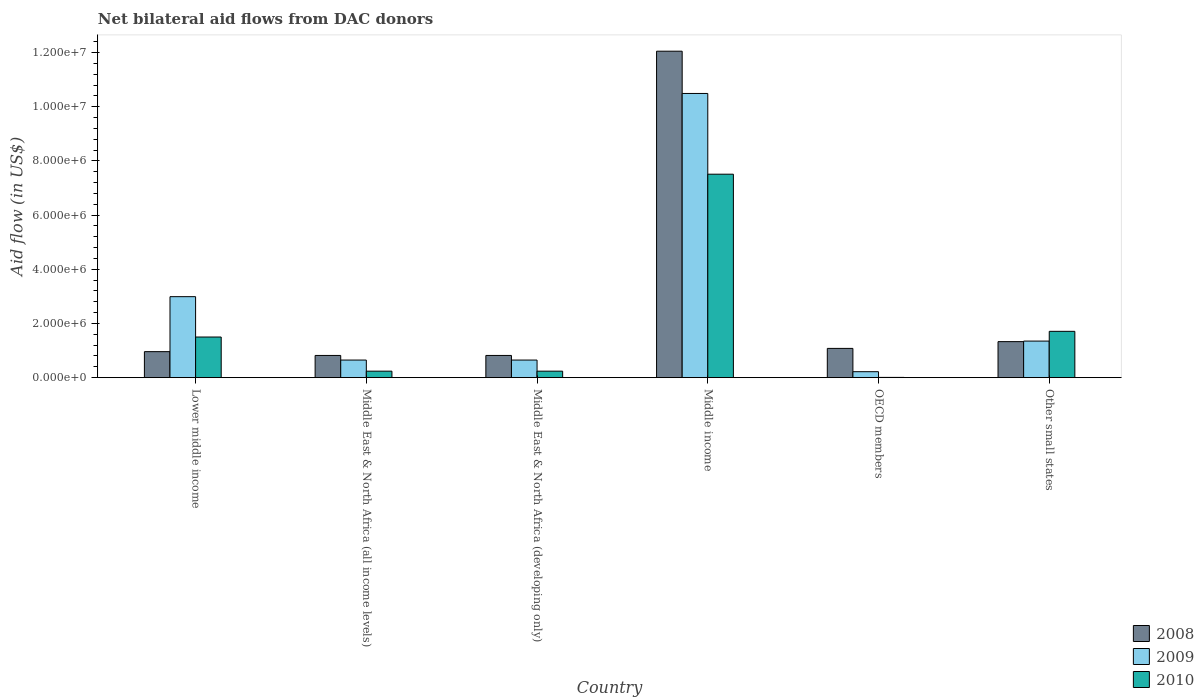How many different coloured bars are there?
Your answer should be very brief. 3. Are the number of bars on each tick of the X-axis equal?
Keep it short and to the point. Yes. How many bars are there on the 1st tick from the left?
Offer a very short reply. 3. How many bars are there on the 4th tick from the right?
Your answer should be very brief. 3. What is the label of the 5th group of bars from the left?
Keep it short and to the point. OECD members. What is the net bilateral aid flow in 2009 in Middle income?
Provide a short and direct response. 1.05e+07. Across all countries, what is the maximum net bilateral aid flow in 2009?
Keep it short and to the point. 1.05e+07. Across all countries, what is the minimum net bilateral aid flow in 2009?
Your response must be concise. 2.20e+05. In which country was the net bilateral aid flow in 2009 minimum?
Offer a terse response. OECD members. What is the total net bilateral aid flow in 2009 in the graph?
Offer a terse response. 1.64e+07. What is the difference between the net bilateral aid flow in 2008 in Middle East & North Africa (developing only) and that in OECD members?
Offer a very short reply. -2.60e+05. What is the difference between the net bilateral aid flow in 2008 in Middle East & North Africa (all income levels) and the net bilateral aid flow in 2010 in Other small states?
Keep it short and to the point. -8.90e+05. What is the average net bilateral aid flow in 2010 per country?
Provide a succinct answer. 1.87e+06. What is the difference between the net bilateral aid flow of/in 2009 and net bilateral aid flow of/in 2010 in Lower middle income?
Your response must be concise. 1.49e+06. In how many countries, is the net bilateral aid flow in 2010 greater than 6800000 US$?
Offer a very short reply. 1. What is the ratio of the net bilateral aid flow in 2008 in Middle East & North Africa (developing only) to that in Other small states?
Offer a very short reply. 0.62. Is the net bilateral aid flow in 2010 in Middle income less than that in OECD members?
Provide a short and direct response. No. Is the difference between the net bilateral aid flow in 2009 in OECD members and Other small states greater than the difference between the net bilateral aid flow in 2010 in OECD members and Other small states?
Provide a succinct answer. Yes. What is the difference between the highest and the second highest net bilateral aid flow in 2008?
Ensure brevity in your answer.  1.07e+07. What is the difference between the highest and the lowest net bilateral aid flow in 2009?
Your answer should be very brief. 1.03e+07. In how many countries, is the net bilateral aid flow in 2009 greater than the average net bilateral aid flow in 2009 taken over all countries?
Offer a very short reply. 2. What does the 1st bar from the left in Other small states represents?
Your response must be concise. 2008. What does the 3rd bar from the right in Middle income represents?
Provide a short and direct response. 2008. How many bars are there?
Offer a very short reply. 18. How many countries are there in the graph?
Offer a terse response. 6. Where does the legend appear in the graph?
Keep it short and to the point. Bottom right. How are the legend labels stacked?
Give a very brief answer. Vertical. What is the title of the graph?
Offer a very short reply. Net bilateral aid flows from DAC donors. Does "1963" appear as one of the legend labels in the graph?
Ensure brevity in your answer.  No. What is the label or title of the X-axis?
Your answer should be very brief. Country. What is the label or title of the Y-axis?
Ensure brevity in your answer.  Aid flow (in US$). What is the Aid flow (in US$) in 2008 in Lower middle income?
Your answer should be very brief. 9.60e+05. What is the Aid flow (in US$) of 2009 in Lower middle income?
Make the answer very short. 2.99e+06. What is the Aid flow (in US$) in 2010 in Lower middle income?
Provide a short and direct response. 1.50e+06. What is the Aid flow (in US$) of 2008 in Middle East & North Africa (all income levels)?
Your response must be concise. 8.20e+05. What is the Aid flow (in US$) of 2009 in Middle East & North Africa (all income levels)?
Your answer should be compact. 6.50e+05. What is the Aid flow (in US$) of 2010 in Middle East & North Africa (all income levels)?
Your answer should be compact. 2.40e+05. What is the Aid flow (in US$) in 2008 in Middle East & North Africa (developing only)?
Your response must be concise. 8.20e+05. What is the Aid flow (in US$) of 2009 in Middle East & North Africa (developing only)?
Give a very brief answer. 6.50e+05. What is the Aid flow (in US$) of 2008 in Middle income?
Keep it short and to the point. 1.20e+07. What is the Aid flow (in US$) in 2009 in Middle income?
Keep it short and to the point. 1.05e+07. What is the Aid flow (in US$) in 2010 in Middle income?
Your answer should be compact. 7.51e+06. What is the Aid flow (in US$) of 2008 in OECD members?
Give a very brief answer. 1.08e+06. What is the Aid flow (in US$) of 2009 in OECD members?
Make the answer very short. 2.20e+05. What is the Aid flow (in US$) of 2010 in OECD members?
Give a very brief answer. 10000. What is the Aid flow (in US$) in 2008 in Other small states?
Keep it short and to the point. 1.33e+06. What is the Aid flow (in US$) of 2009 in Other small states?
Provide a short and direct response. 1.35e+06. What is the Aid flow (in US$) in 2010 in Other small states?
Your response must be concise. 1.71e+06. Across all countries, what is the maximum Aid flow (in US$) of 2008?
Offer a terse response. 1.20e+07. Across all countries, what is the maximum Aid flow (in US$) of 2009?
Your response must be concise. 1.05e+07. Across all countries, what is the maximum Aid flow (in US$) in 2010?
Keep it short and to the point. 7.51e+06. Across all countries, what is the minimum Aid flow (in US$) of 2008?
Give a very brief answer. 8.20e+05. Across all countries, what is the minimum Aid flow (in US$) in 2009?
Provide a succinct answer. 2.20e+05. Across all countries, what is the minimum Aid flow (in US$) in 2010?
Keep it short and to the point. 10000. What is the total Aid flow (in US$) in 2008 in the graph?
Give a very brief answer. 1.71e+07. What is the total Aid flow (in US$) of 2009 in the graph?
Your response must be concise. 1.64e+07. What is the total Aid flow (in US$) of 2010 in the graph?
Offer a very short reply. 1.12e+07. What is the difference between the Aid flow (in US$) in 2009 in Lower middle income and that in Middle East & North Africa (all income levels)?
Make the answer very short. 2.34e+06. What is the difference between the Aid flow (in US$) in 2010 in Lower middle income and that in Middle East & North Africa (all income levels)?
Offer a terse response. 1.26e+06. What is the difference between the Aid flow (in US$) in 2008 in Lower middle income and that in Middle East & North Africa (developing only)?
Offer a very short reply. 1.40e+05. What is the difference between the Aid flow (in US$) of 2009 in Lower middle income and that in Middle East & North Africa (developing only)?
Offer a terse response. 2.34e+06. What is the difference between the Aid flow (in US$) of 2010 in Lower middle income and that in Middle East & North Africa (developing only)?
Keep it short and to the point. 1.26e+06. What is the difference between the Aid flow (in US$) in 2008 in Lower middle income and that in Middle income?
Ensure brevity in your answer.  -1.11e+07. What is the difference between the Aid flow (in US$) of 2009 in Lower middle income and that in Middle income?
Give a very brief answer. -7.50e+06. What is the difference between the Aid flow (in US$) in 2010 in Lower middle income and that in Middle income?
Offer a very short reply. -6.01e+06. What is the difference between the Aid flow (in US$) in 2008 in Lower middle income and that in OECD members?
Give a very brief answer. -1.20e+05. What is the difference between the Aid flow (in US$) of 2009 in Lower middle income and that in OECD members?
Offer a terse response. 2.77e+06. What is the difference between the Aid flow (in US$) of 2010 in Lower middle income and that in OECD members?
Provide a succinct answer. 1.49e+06. What is the difference between the Aid flow (in US$) in 2008 in Lower middle income and that in Other small states?
Provide a short and direct response. -3.70e+05. What is the difference between the Aid flow (in US$) of 2009 in Lower middle income and that in Other small states?
Keep it short and to the point. 1.64e+06. What is the difference between the Aid flow (in US$) of 2009 in Middle East & North Africa (all income levels) and that in Middle East & North Africa (developing only)?
Provide a succinct answer. 0. What is the difference between the Aid flow (in US$) of 2008 in Middle East & North Africa (all income levels) and that in Middle income?
Make the answer very short. -1.12e+07. What is the difference between the Aid flow (in US$) in 2009 in Middle East & North Africa (all income levels) and that in Middle income?
Offer a very short reply. -9.84e+06. What is the difference between the Aid flow (in US$) of 2010 in Middle East & North Africa (all income levels) and that in Middle income?
Keep it short and to the point. -7.27e+06. What is the difference between the Aid flow (in US$) of 2009 in Middle East & North Africa (all income levels) and that in OECD members?
Your response must be concise. 4.30e+05. What is the difference between the Aid flow (in US$) of 2010 in Middle East & North Africa (all income levels) and that in OECD members?
Offer a terse response. 2.30e+05. What is the difference between the Aid flow (in US$) in 2008 in Middle East & North Africa (all income levels) and that in Other small states?
Provide a short and direct response. -5.10e+05. What is the difference between the Aid flow (in US$) in 2009 in Middle East & North Africa (all income levels) and that in Other small states?
Keep it short and to the point. -7.00e+05. What is the difference between the Aid flow (in US$) of 2010 in Middle East & North Africa (all income levels) and that in Other small states?
Give a very brief answer. -1.47e+06. What is the difference between the Aid flow (in US$) in 2008 in Middle East & North Africa (developing only) and that in Middle income?
Give a very brief answer. -1.12e+07. What is the difference between the Aid flow (in US$) of 2009 in Middle East & North Africa (developing only) and that in Middle income?
Give a very brief answer. -9.84e+06. What is the difference between the Aid flow (in US$) of 2010 in Middle East & North Africa (developing only) and that in Middle income?
Ensure brevity in your answer.  -7.27e+06. What is the difference between the Aid flow (in US$) in 2008 in Middle East & North Africa (developing only) and that in OECD members?
Make the answer very short. -2.60e+05. What is the difference between the Aid flow (in US$) of 2009 in Middle East & North Africa (developing only) and that in OECD members?
Provide a short and direct response. 4.30e+05. What is the difference between the Aid flow (in US$) of 2008 in Middle East & North Africa (developing only) and that in Other small states?
Ensure brevity in your answer.  -5.10e+05. What is the difference between the Aid flow (in US$) in 2009 in Middle East & North Africa (developing only) and that in Other small states?
Your answer should be very brief. -7.00e+05. What is the difference between the Aid flow (in US$) of 2010 in Middle East & North Africa (developing only) and that in Other small states?
Make the answer very short. -1.47e+06. What is the difference between the Aid flow (in US$) of 2008 in Middle income and that in OECD members?
Your answer should be very brief. 1.10e+07. What is the difference between the Aid flow (in US$) in 2009 in Middle income and that in OECD members?
Your answer should be compact. 1.03e+07. What is the difference between the Aid flow (in US$) of 2010 in Middle income and that in OECD members?
Offer a very short reply. 7.50e+06. What is the difference between the Aid flow (in US$) in 2008 in Middle income and that in Other small states?
Your response must be concise. 1.07e+07. What is the difference between the Aid flow (in US$) in 2009 in Middle income and that in Other small states?
Give a very brief answer. 9.14e+06. What is the difference between the Aid flow (in US$) in 2010 in Middle income and that in Other small states?
Keep it short and to the point. 5.80e+06. What is the difference between the Aid flow (in US$) in 2009 in OECD members and that in Other small states?
Offer a terse response. -1.13e+06. What is the difference between the Aid flow (in US$) in 2010 in OECD members and that in Other small states?
Ensure brevity in your answer.  -1.70e+06. What is the difference between the Aid flow (in US$) in 2008 in Lower middle income and the Aid flow (in US$) in 2009 in Middle East & North Africa (all income levels)?
Make the answer very short. 3.10e+05. What is the difference between the Aid flow (in US$) in 2008 in Lower middle income and the Aid flow (in US$) in 2010 in Middle East & North Africa (all income levels)?
Offer a very short reply. 7.20e+05. What is the difference between the Aid flow (in US$) of 2009 in Lower middle income and the Aid flow (in US$) of 2010 in Middle East & North Africa (all income levels)?
Your answer should be compact. 2.75e+06. What is the difference between the Aid flow (in US$) of 2008 in Lower middle income and the Aid flow (in US$) of 2010 in Middle East & North Africa (developing only)?
Ensure brevity in your answer.  7.20e+05. What is the difference between the Aid flow (in US$) in 2009 in Lower middle income and the Aid flow (in US$) in 2010 in Middle East & North Africa (developing only)?
Your response must be concise. 2.75e+06. What is the difference between the Aid flow (in US$) of 2008 in Lower middle income and the Aid flow (in US$) of 2009 in Middle income?
Your answer should be very brief. -9.53e+06. What is the difference between the Aid flow (in US$) in 2008 in Lower middle income and the Aid flow (in US$) in 2010 in Middle income?
Offer a very short reply. -6.55e+06. What is the difference between the Aid flow (in US$) of 2009 in Lower middle income and the Aid flow (in US$) of 2010 in Middle income?
Provide a short and direct response. -4.52e+06. What is the difference between the Aid flow (in US$) of 2008 in Lower middle income and the Aid flow (in US$) of 2009 in OECD members?
Offer a terse response. 7.40e+05. What is the difference between the Aid flow (in US$) of 2008 in Lower middle income and the Aid flow (in US$) of 2010 in OECD members?
Ensure brevity in your answer.  9.50e+05. What is the difference between the Aid flow (in US$) of 2009 in Lower middle income and the Aid flow (in US$) of 2010 in OECD members?
Keep it short and to the point. 2.98e+06. What is the difference between the Aid flow (in US$) of 2008 in Lower middle income and the Aid flow (in US$) of 2009 in Other small states?
Provide a short and direct response. -3.90e+05. What is the difference between the Aid flow (in US$) in 2008 in Lower middle income and the Aid flow (in US$) in 2010 in Other small states?
Offer a terse response. -7.50e+05. What is the difference between the Aid flow (in US$) of 2009 in Lower middle income and the Aid flow (in US$) of 2010 in Other small states?
Offer a terse response. 1.28e+06. What is the difference between the Aid flow (in US$) in 2008 in Middle East & North Africa (all income levels) and the Aid flow (in US$) in 2009 in Middle East & North Africa (developing only)?
Give a very brief answer. 1.70e+05. What is the difference between the Aid flow (in US$) in 2008 in Middle East & North Africa (all income levels) and the Aid flow (in US$) in 2010 in Middle East & North Africa (developing only)?
Offer a very short reply. 5.80e+05. What is the difference between the Aid flow (in US$) of 2009 in Middle East & North Africa (all income levels) and the Aid flow (in US$) of 2010 in Middle East & North Africa (developing only)?
Offer a terse response. 4.10e+05. What is the difference between the Aid flow (in US$) in 2008 in Middle East & North Africa (all income levels) and the Aid flow (in US$) in 2009 in Middle income?
Provide a short and direct response. -9.67e+06. What is the difference between the Aid flow (in US$) of 2008 in Middle East & North Africa (all income levels) and the Aid flow (in US$) of 2010 in Middle income?
Your answer should be very brief. -6.69e+06. What is the difference between the Aid flow (in US$) of 2009 in Middle East & North Africa (all income levels) and the Aid flow (in US$) of 2010 in Middle income?
Keep it short and to the point. -6.86e+06. What is the difference between the Aid flow (in US$) of 2008 in Middle East & North Africa (all income levels) and the Aid flow (in US$) of 2010 in OECD members?
Offer a terse response. 8.10e+05. What is the difference between the Aid flow (in US$) of 2009 in Middle East & North Africa (all income levels) and the Aid flow (in US$) of 2010 in OECD members?
Offer a terse response. 6.40e+05. What is the difference between the Aid flow (in US$) of 2008 in Middle East & North Africa (all income levels) and the Aid flow (in US$) of 2009 in Other small states?
Your response must be concise. -5.30e+05. What is the difference between the Aid flow (in US$) of 2008 in Middle East & North Africa (all income levels) and the Aid flow (in US$) of 2010 in Other small states?
Ensure brevity in your answer.  -8.90e+05. What is the difference between the Aid flow (in US$) in 2009 in Middle East & North Africa (all income levels) and the Aid flow (in US$) in 2010 in Other small states?
Make the answer very short. -1.06e+06. What is the difference between the Aid flow (in US$) in 2008 in Middle East & North Africa (developing only) and the Aid flow (in US$) in 2009 in Middle income?
Keep it short and to the point. -9.67e+06. What is the difference between the Aid flow (in US$) in 2008 in Middle East & North Africa (developing only) and the Aid flow (in US$) in 2010 in Middle income?
Provide a short and direct response. -6.69e+06. What is the difference between the Aid flow (in US$) in 2009 in Middle East & North Africa (developing only) and the Aid flow (in US$) in 2010 in Middle income?
Ensure brevity in your answer.  -6.86e+06. What is the difference between the Aid flow (in US$) of 2008 in Middle East & North Africa (developing only) and the Aid flow (in US$) of 2009 in OECD members?
Give a very brief answer. 6.00e+05. What is the difference between the Aid flow (in US$) of 2008 in Middle East & North Africa (developing only) and the Aid flow (in US$) of 2010 in OECD members?
Your response must be concise. 8.10e+05. What is the difference between the Aid flow (in US$) in 2009 in Middle East & North Africa (developing only) and the Aid flow (in US$) in 2010 in OECD members?
Your response must be concise. 6.40e+05. What is the difference between the Aid flow (in US$) in 2008 in Middle East & North Africa (developing only) and the Aid flow (in US$) in 2009 in Other small states?
Provide a succinct answer. -5.30e+05. What is the difference between the Aid flow (in US$) of 2008 in Middle East & North Africa (developing only) and the Aid flow (in US$) of 2010 in Other small states?
Give a very brief answer. -8.90e+05. What is the difference between the Aid flow (in US$) in 2009 in Middle East & North Africa (developing only) and the Aid flow (in US$) in 2010 in Other small states?
Your response must be concise. -1.06e+06. What is the difference between the Aid flow (in US$) of 2008 in Middle income and the Aid flow (in US$) of 2009 in OECD members?
Give a very brief answer. 1.18e+07. What is the difference between the Aid flow (in US$) of 2008 in Middle income and the Aid flow (in US$) of 2010 in OECD members?
Offer a terse response. 1.20e+07. What is the difference between the Aid flow (in US$) in 2009 in Middle income and the Aid flow (in US$) in 2010 in OECD members?
Offer a terse response. 1.05e+07. What is the difference between the Aid flow (in US$) of 2008 in Middle income and the Aid flow (in US$) of 2009 in Other small states?
Offer a very short reply. 1.07e+07. What is the difference between the Aid flow (in US$) of 2008 in Middle income and the Aid flow (in US$) of 2010 in Other small states?
Offer a very short reply. 1.03e+07. What is the difference between the Aid flow (in US$) in 2009 in Middle income and the Aid flow (in US$) in 2010 in Other small states?
Offer a very short reply. 8.78e+06. What is the difference between the Aid flow (in US$) of 2008 in OECD members and the Aid flow (in US$) of 2010 in Other small states?
Make the answer very short. -6.30e+05. What is the difference between the Aid flow (in US$) in 2009 in OECD members and the Aid flow (in US$) in 2010 in Other small states?
Provide a succinct answer. -1.49e+06. What is the average Aid flow (in US$) in 2008 per country?
Keep it short and to the point. 2.84e+06. What is the average Aid flow (in US$) of 2009 per country?
Your answer should be compact. 2.72e+06. What is the average Aid flow (in US$) in 2010 per country?
Keep it short and to the point. 1.87e+06. What is the difference between the Aid flow (in US$) in 2008 and Aid flow (in US$) in 2009 in Lower middle income?
Give a very brief answer. -2.03e+06. What is the difference between the Aid flow (in US$) of 2008 and Aid flow (in US$) of 2010 in Lower middle income?
Your response must be concise. -5.40e+05. What is the difference between the Aid flow (in US$) of 2009 and Aid flow (in US$) of 2010 in Lower middle income?
Offer a very short reply. 1.49e+06. What is the difference between the Aid flow (in US$) of 2008 and Aid flow (in US$) of 2010 in Middle East & North Africa (all income levels)?
Ensure brevity in your answer.  5.80e+05. What is the difference between the Aid flow (in US$) in 2009 and Aid flow (in US$) in 2010 in Middle East & North Africa (all income levels)?
Your response must be concise. 4.10e+05. What is the difference between the Aid flow (in US$) in 2008 and Aid flow (in US$) in 2010 in Middle East & North Africa (developing only)?
Your response must be concise. 5.80e+05. What is the difference between the Aid flow (in US$) of 2008 and Aid flow (in US$) of 2009 in Middle income?
Make the answer very short. 1.56e+06. What is the difference between the Aid flow (in US$) of 2008 and Aid flow (in US$) of 2010 in Middle income?
Provide a succinct answer. 4.54e+06. What is the difference between the Aid flow (in US$) in 2009 and Aid flow (in US$) in 2010 in Middle income?
Make the answer very short. 2.98e+06. What is the difference between the Aid flow (in US$) of 2008 and Aid flow (in US$) of 2009 in OECD members?
Offer a terse response. 8.60e+05. What is the difference between the Aid flow (in US$) in 2008 and Aid flow (in US$) in 2010 in OECD members?
Keep it short and to the point. 1.07e+06. What is the difference between the Aid flow (in US$) in 2008 and Aid flow (in US$) in 2010 in Other small states?
Your answer should be very brief. -3.80e+05. What is the difference between the Aid flow (in US$) of 2009 and Aid flow (in US$) of 2010 in Other small states?
Your response must be concise. -3.60e+05. What is the ratio of the Aid flow (in US$) in 2008 in Lower middle income to that in Middle East & North Africa (all income levels)?
Ensure brevity in your answer.  1.17. What is the ratio of the Aid flow (in US$) in 2010 in Lower middle income to that in Middle East & North Africa (all income levels)?
Your response must be concise. 6.25. What is the ratio of the Aid flow (in US$) of 2008 in Lower middle income to that in Middle East & North Africa (developing only)?
Provide a succinct answer. 1.17. What is the ratio of the Aid flow (in US$) in 2009 in Lower middle income to that in Middle East & North Africa (developing only)?
Keep it short and to the point. 4.6. What is the ratio of the Aid flow (in US$) in 2010 in Lower middle income to that in Middle East & North Africa (developing only)?
Offer a terse response. 6.25. What is the ratio of the Aid flow (in US$) of 2008 in Lower middle income to that in Middle income?
Ensure brevity in your answer.  0.08. What is the ratio of the Aid flow (in US$) of 2009 in Lower middle income to that in Middle income?
Provide a short and direct response. 0.28. What is the ratio of the Aid flow (in US$) of 2010 in Lower middle income to that in Middle income?
Your answer should be compact. 0.2. What is the ratio of the Aid flow (in US$) in 2008 in Lower middle income to that in OECD members?
Ensure brevity in your answer.  0.89. What is the ratio of the Aid flow (in US$) in 2009 in Lower middle income to that in OECD members?
Make the answer very short. 13.59. What is the ratio of the Aid flow (in US$) of 2010 in Lower middle income to that in OECD members?
Give a very brief answer. 150. What is the ratio of the Aid flow (in US$) in 2008 in Lower middle income to that in Other small states?
Your response must be concise. 0.72. What is the ratio of the Aid flow (in US$) of 2009 in Lower middle income to that in Other small states?
Provide a succinct answer. 2.21. What is the ratio of the Aid flow (in US$) of 2010 in Lower middle income to that in Other small states?
Your answer should be very brief. 0.88. What is the ratio of the Aid flow (in US$) in 2009 in Middle East & North Africa (all income levels) to that in Middle East & North Africa (developing only)?
Offer a terse response. 1. What is the ratio of the Aid flow (in US$) in 2010 in Middle East & North Africa (all income levels) to that in Middle East & North Africa (developing only)?
Give a very brief answer. 1. What is the ratio of the Aid flow (in US$) of 2008 in Middle East & North Africa (all income levels) to that in Middle income?
Your response must be concise. 0.07. What is the ratio of the Aid flow (in US$) in 2009 in Middle East & North Africa (all income levels) to that in Middle income?
Provide a succinct answer. 0.06. What is the ratio of the Aid flow (in US$) in 2010 in Middle East & North Africa (all income levels) to that in Middle income?
Offer a terse response. 0.03. What is the ratio of the Aid flow (in US$) in 2008 in Middle East & North Africa (all income levels) to that in OECD members?
Your answer should be very brief. 0.76. What is the ratio of the Aid flow (in US$) in 2009 in Middle East & North Africa (all income levels) to that in OECD members?
Provide a short and direct response. 2.95. What is the ratio of the Aid flow (in US$) in 2008 in Middle East & North Africa (all income levels) to that in Other small states?
Offer a very short reply. 0.62. What is the ratio of the Aid flow (in US$) of 2009 in Middle East & North Africa (all income levels) to that in Other small states?
Make the answer very short. 0.48. What is the ratio of the Aid flow (in US$) in 2010 in Middle East & North Africa (all income levels) to that in Other small states?
Provide a succinct answer. 0.14. What is the ratio of the Aid flow (in US$) of 2008 in Middle East & North Africa (developing only) to that in Middle income?
Your response must be concise. 0.07. What is the ratio of the Aid flow (in US$) of 2009 in Middle East & North Africa (developing only) to that in Middle income?
Your response must be concise. 0.06. What is the ratio of the Aid flow (in US$) in 2010 in Middle East & North Africa (developing only) to that in Middle income?
Your response must be concise. 0.03. What is the ratio of the Aid flow (in US$) in 2008 in Middle East & North Africa (developing only) to that in OECD members?
Ensure brevity in your answer.  0.76. What is the ratio of the Aid flow (in US$) in 2009 in Middle East & North Africa (developing only) to that in OECD members?
Provide a short and direct response. 2.95. What is the ratio of the Aid flow (in US$) of 2008 in Middle East & North Africa (developing only) to that in Other small states?
Keep it short and to the point. 0.62. What is the ratio of the Aid flow (in US$) in 2009 in Middle East & North Africa (developing only) to that in Other small states?
Ensure brevity in your answer.  0.48. What is the ratio of the Aid flow (in US$) in 2010 in Middle East & North Africa (developing only) to that in Other small states?
Offer a very short reply. 0.14. What is the ratio of the Aid flow (in US$) of 2008 in Middle income to that in OECD members?
Provide a succinct answer. 11.16. What is the ratio of the Aid flow (in US$) in 2009 in Middle income to that in OECD members?
Your answer should be compact. 47.68. What is the ratio of the Aid flow (in US$) of 2010 in Middle income to that in OECD members?
Your response must be concise. 751. What is the ratio of the Aid flow (in US$) in 2008 in Middle income to that in Other small states?
Provide a succinct answer. 9.06. What is the ratio of the Aid flow (in US$) in 2009 in Middle income to that in Other small states?
Offer a terse response. 7.77. What is the ratio of the Aid flow (in US$) of 2010 in Middle income to that in Other small states?
Your response must be concise. 4.39. What is the ratio of the Aid flow (in US$) of 2008 in OECD members to that in Other small states?
Make the answer very short. 0.81. What is the ratio of the Aid flow (in US$) in 2009 in OECD members to that in Other small states?
Offer a terse response. 0.16. What is the ratio of the Aid flow (in US$) in 2010 in OECD members to that in Other small states?
Your response must be concise. 0.01. What is the difference between the highest and the second highest Aid flow (in US$) in 2008?
Provide a succinct answer. 1.07e+07. What is the difference between the highest and the second highest Aid flow (in US$) in 2009?
Provide a short and direct response. 7.50e+06. What is the difference between the highest and the second highest Aid flow (in US$) of 2010?
Give a very brief answer. 5.80e+06. What is the difference between the highest and the lowest Aid flow (in US$) in 2008?
Your answer should be very brief. 1.12e+07. What is the difference between the highest and the lowest Aid flow (in US$) of 2009?
Keep it short and to the point. 1.03e+07. What is the difference between the highest and the lowest Aid flow (in US$) of 2010?
Make the answer very short. 7.50e+06. 